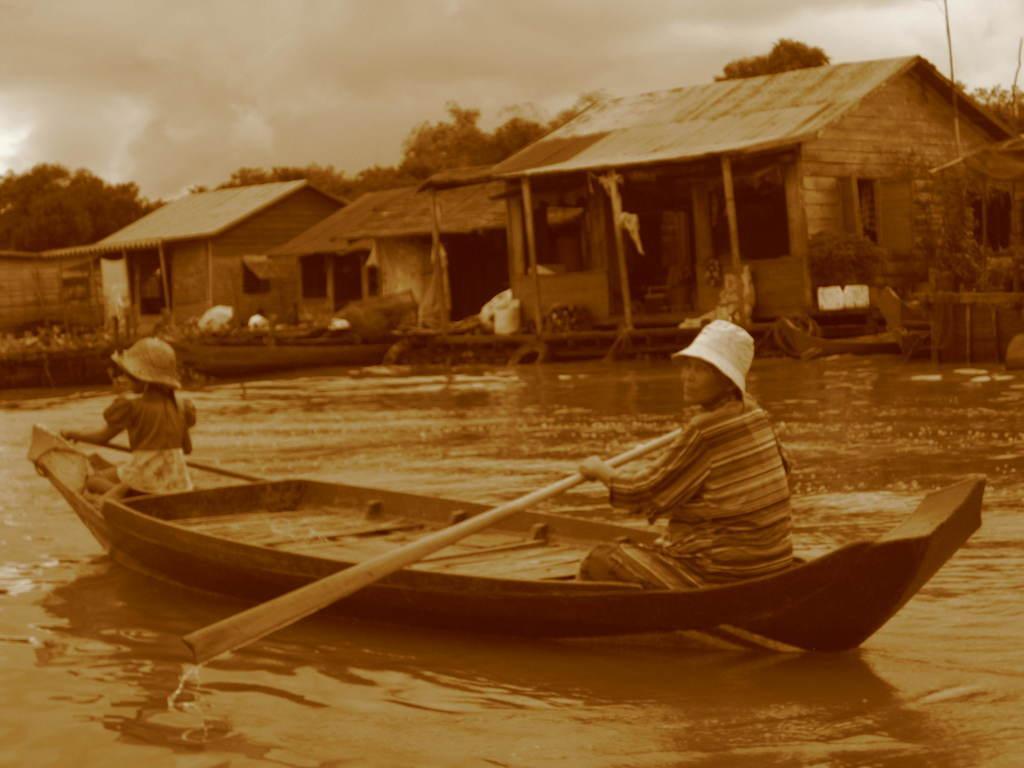How would you summarize this image in a sentence or two? In this image we can see two persons wearing caps are sitting on a boat. They are rowing the boat with paddles. And the boat is on the water. In the back there are houses. In the background there are trees and sky. 